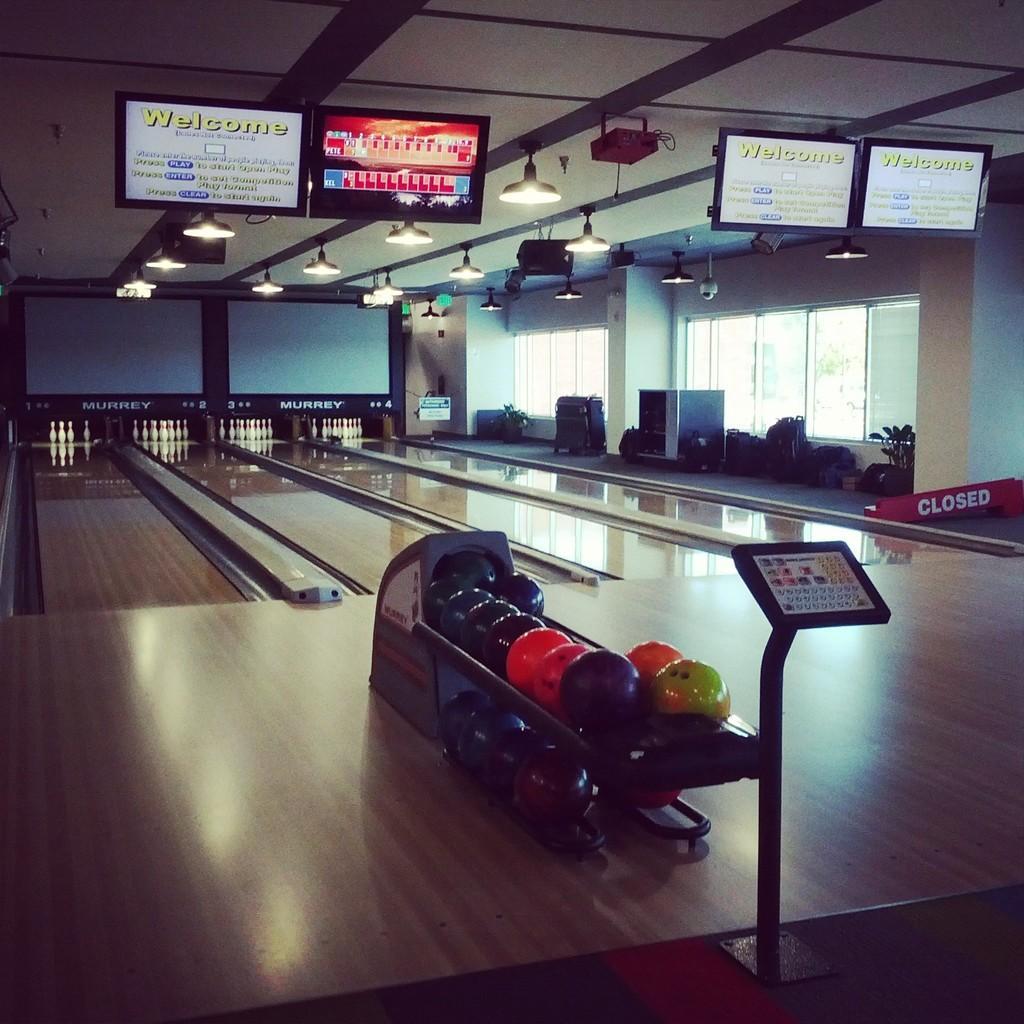Can you describe this image briefly? In the image we can see there are iron balls kept on the stand and there are bowling pins kept on the floor. It's written ¨Closed¨ on the banner and there are tv screen on the top. There is a projector and there are lights on the top. 